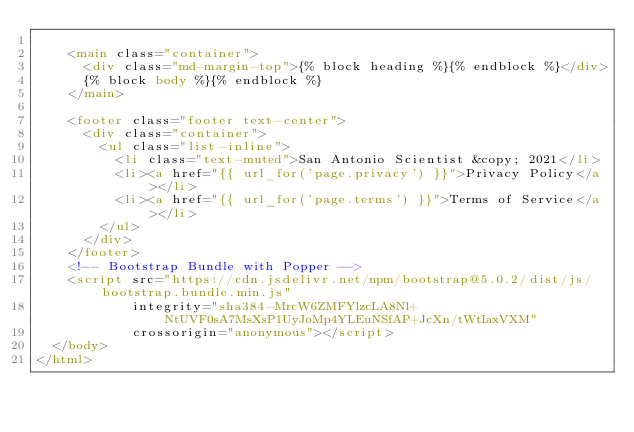<code> <loc_0><loc_0><loc_500><loc_500><_HTML_>
    <main class="container">
      <div class="md-margin-top">{% block heading %}{% endblock %}</div>
      {% block body %}{% endblock %}
    </main>

    <footer class="footer text-center">
      <div class="container">
        <ul class="list-inline">
          <li class="text-muted">San Antonio Scientist &copy; 2021</li>
          <li><a href="{{ url_for('page.privacy') }}">Privacy Policy</a></li>
          <li><a href="{{ url_for('page.terms') }}">Terms of Service</a></li>
        </ul>
      </div>
    </footer>
    <!-- Bootstrap Bundle with Popper -->
    <script src="https://cdn.jsdelivr.net/npm/bootstrap@5.0.2/dist/js/bootstrap.bundle.min.js" 
            integrity="sha384-MrcW6ZMFYlzcLA8Nl+NtUVF0sA7MsXsP1UyJoMp4YLEuNSfAP+JcXn/tWtIaxVXM" 
            crossorigin="anonymous"></script>
  </body>
</html>
</code> 